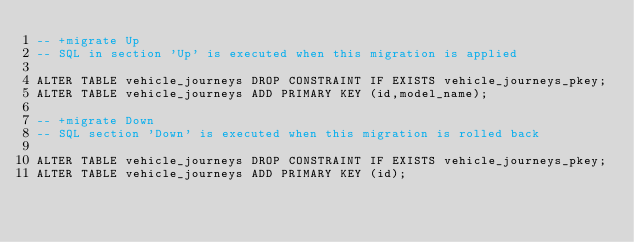Convert code to text. <code><loc_0><loc_0><loc_500><loc_500><_SQL_>-- +migrate Up
-- SQL in section 'Up' is executed when this migration is applied

ALTER TABLE vehicle_journeys DROP CONSTRAINT IF EXISTS vehicle_journeys_pkey;
ALTER TABLE vehicle_journeys ADD PRIMARY KEY (id,model_name);

-- +migrate Down
-- SQL section 'Down' is executed when this migration is rolled back

ALTER TABLE vehicle_journeys DROP CONSTRAINT IF EXISTS vehicle_journeys_pkey;
ALTER TABLE vehicle_journeys ADD PRIMARY KEY (id);</code> 